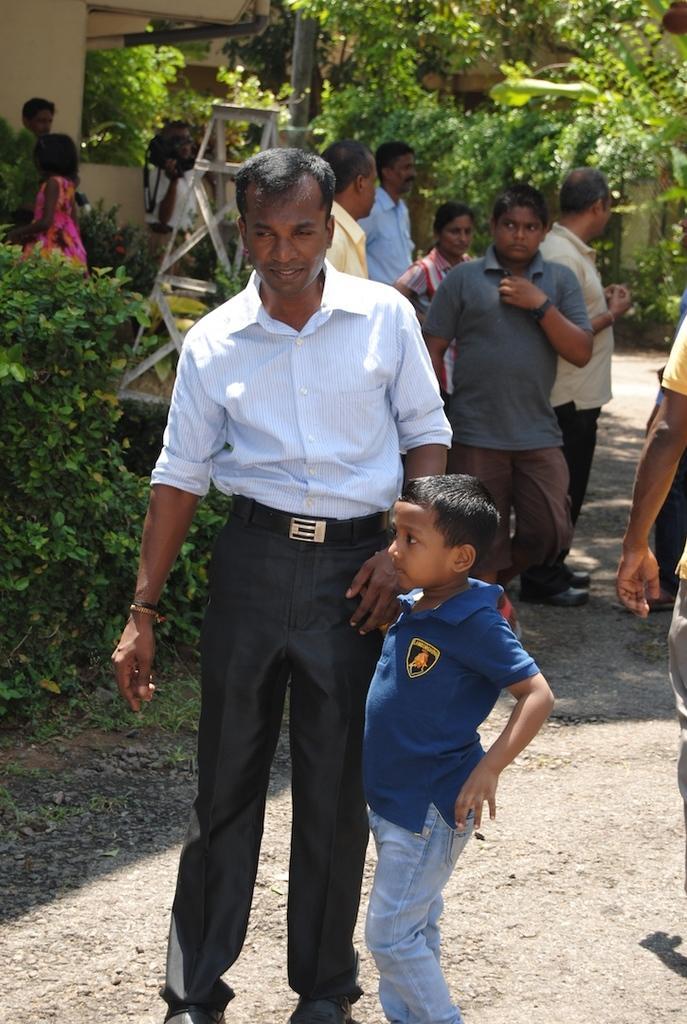In one or two sentences, can you explain what this image depicts? There is a man standing,beside this man we can see a boy. in the background we can see plants,people,ladder,wall and trees. 